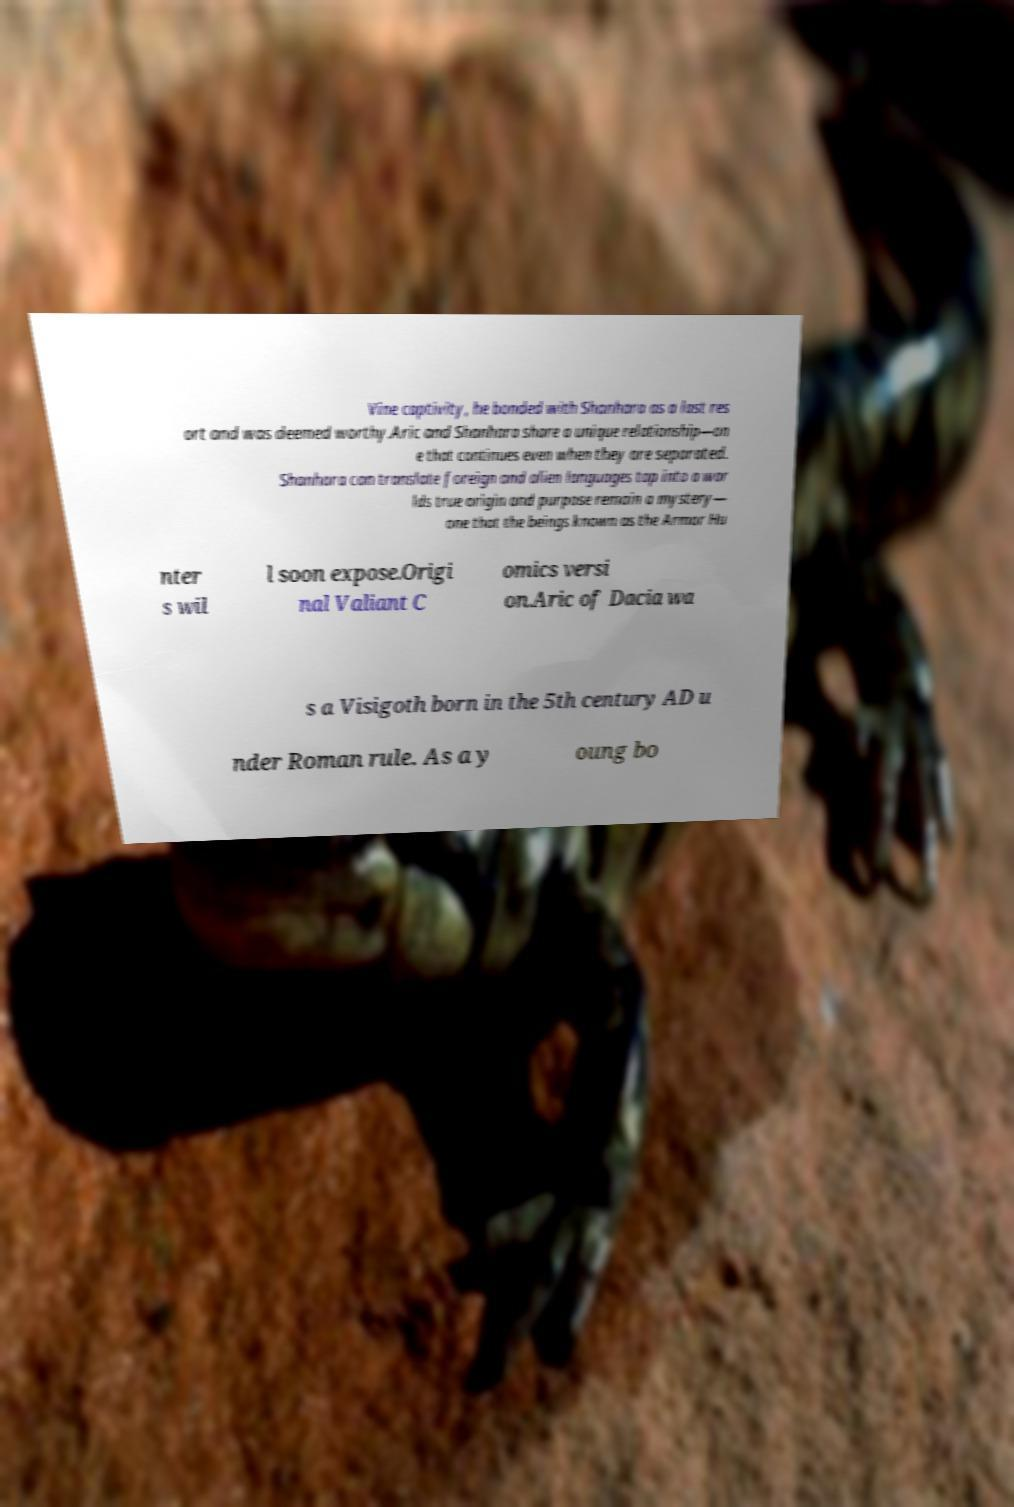What messages or text are displayed in this image? I need them in a readable, typed format. Vine captivity, he bonded with Shanhara as a last res ort and was deemed worthy.Aric and Shanhara share a unique relationship—on e that continues even when they are separated. Shanhara can translate foreign and alien languages tap into a wor lds true origin and purpose remain a mystery— one that the beings known as the Armor Hu nter s wil l soon expose.Origi nal Valiant C omics versi on.Aric of Dacia wa s a Visigoth born in the 5th century AD u nder Roman rule. As a y oung bo 